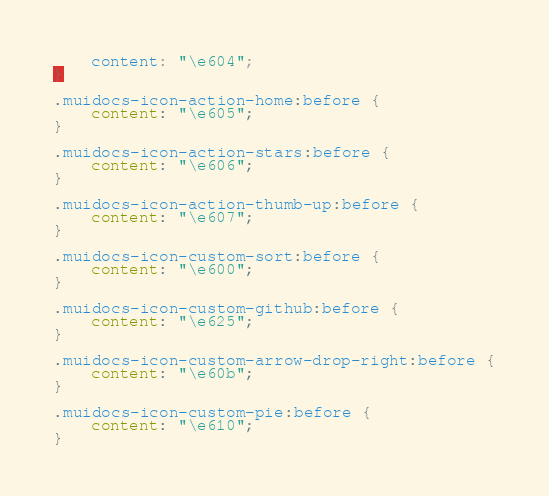Convert code to text. <code><loc_0><loc_0><loc_500><loc_500><_CSS_>    content: "\e604";
}

.muidocs-icon-action-home:before {
    content: "\e605";
}

.muidocs-icon-action-stars:before {
    content: "\e606";
}

.muidocs-icon-action-thumb-up:before {
    content: "\e607";
}

.muidocs-icon-custom-sort:before {
    content: "\e600";
}

.muidocs-icon-custom-github:before {
    content: "\e625";
}

.muidocs-icon-custom-arrow-drop-right:before {
    content: "\e60b";
}

.muidocs-icon-custom-pie:before {
    content: "\e610";
}</code> 